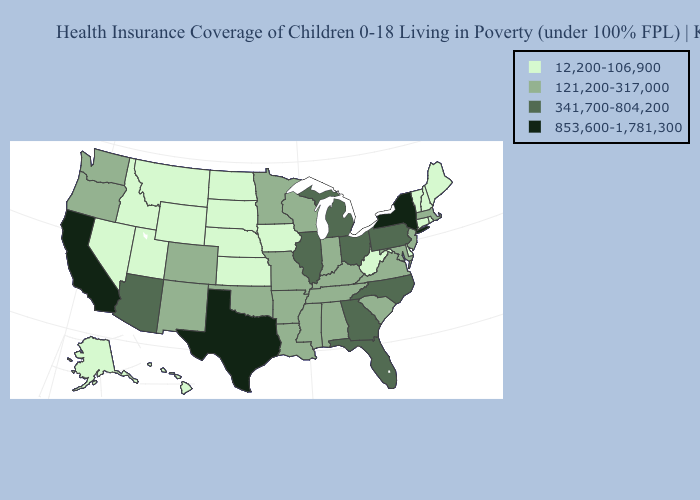What is the value of Massachusetts?
Answer briefly. 121,200-317,000. What is the highest value in states that border Montana?
Concise answer only. 12,200-106,900. Name the states that have a value in the range 853,600-1,781,300?
Quick response, please. California, New York, Texas. Name the states that have a value in the range 853,600-1,781,300?
Be succinct. California, New York, Texas. Among the states that border Iowa , which have the lowest value?
Quick response, please. Nebraska, South Dakota. What is the highest value in states that border Vermont?
Keep it brief. 853,600-1,781,300. What is the highest value in states that border Idaho?
Be succinct. 121,200-317,000. Name the states that have a value in the range 853,600-1,781,300?
Be succinct. California, New York, Texas. What is the value of Pennsylvania?
Quick response, please. 341,700-804,200. Among the states that border Wisconsin , which have the lowest value?
Write a very short answer. Iowa. What is the highest value in the USA?
Write a very short answer. 853,600-1,781,300. What is the value of Wyoming?
Keep it brief. 12,200-106,900. What is the value of New Mexico?
Give a very brief answer. 121,200-317,000. Name the states that have a value in the range 853,600-1,781,300?
Keep it brief. California, New York, Texas. What is the value of Texas?
Write a very short answer. 853,600-1,781,300. 